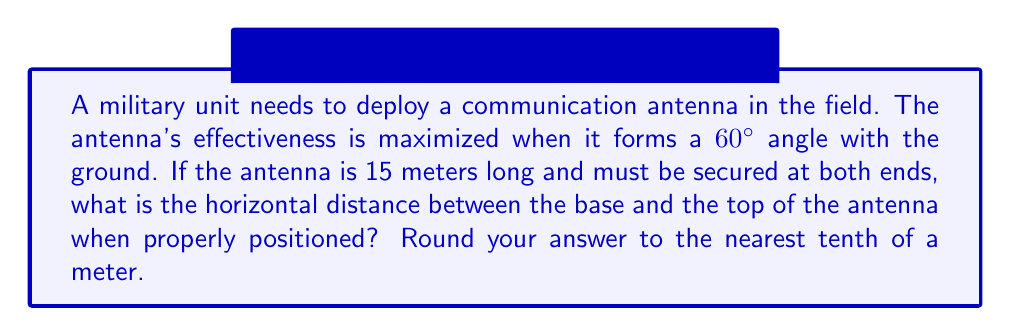Solve this math problem. Let's approach this step-by-step:

1) We can model this situation as a right triangle, where:
   - The antenna forms the hypotenuse
   - The ground forms the base
   - The vertical height of the antenna forms the opposite side

2) We know:
   - The hypotenuse (antenna length) is 15 meters
   - The angle between the ground and the antenna is 60°
   - We need to find the base (horizontal distance)

3) In a right triangle, we can use trigonometric ratios. For the cosine function:

   $$\cos \theta = \frac{\text{adjacent}}{\text{hypotenuse}}$$

4) In our case:
   $$\cos 60° = \frac{\text{horizontal distance}}{15}$$

5) We know that $\cos 60° = \frac{1}{2}$, so:

   $$\frac{1}{2} = \frac{\text{horizontal distance}}{15}$$

6) Solving for the horizontal distance:

   $$\text{horizontal distance} = 15 * \frac{1}{2} = 7.5 \text{ meters}$$

7) Rounding to the nearest tenth:

   7.5 meters

This distance ensures the antenna is deployed at the optimal 60° angle for maximum effectiveness.
Answer: 7.5 meters 